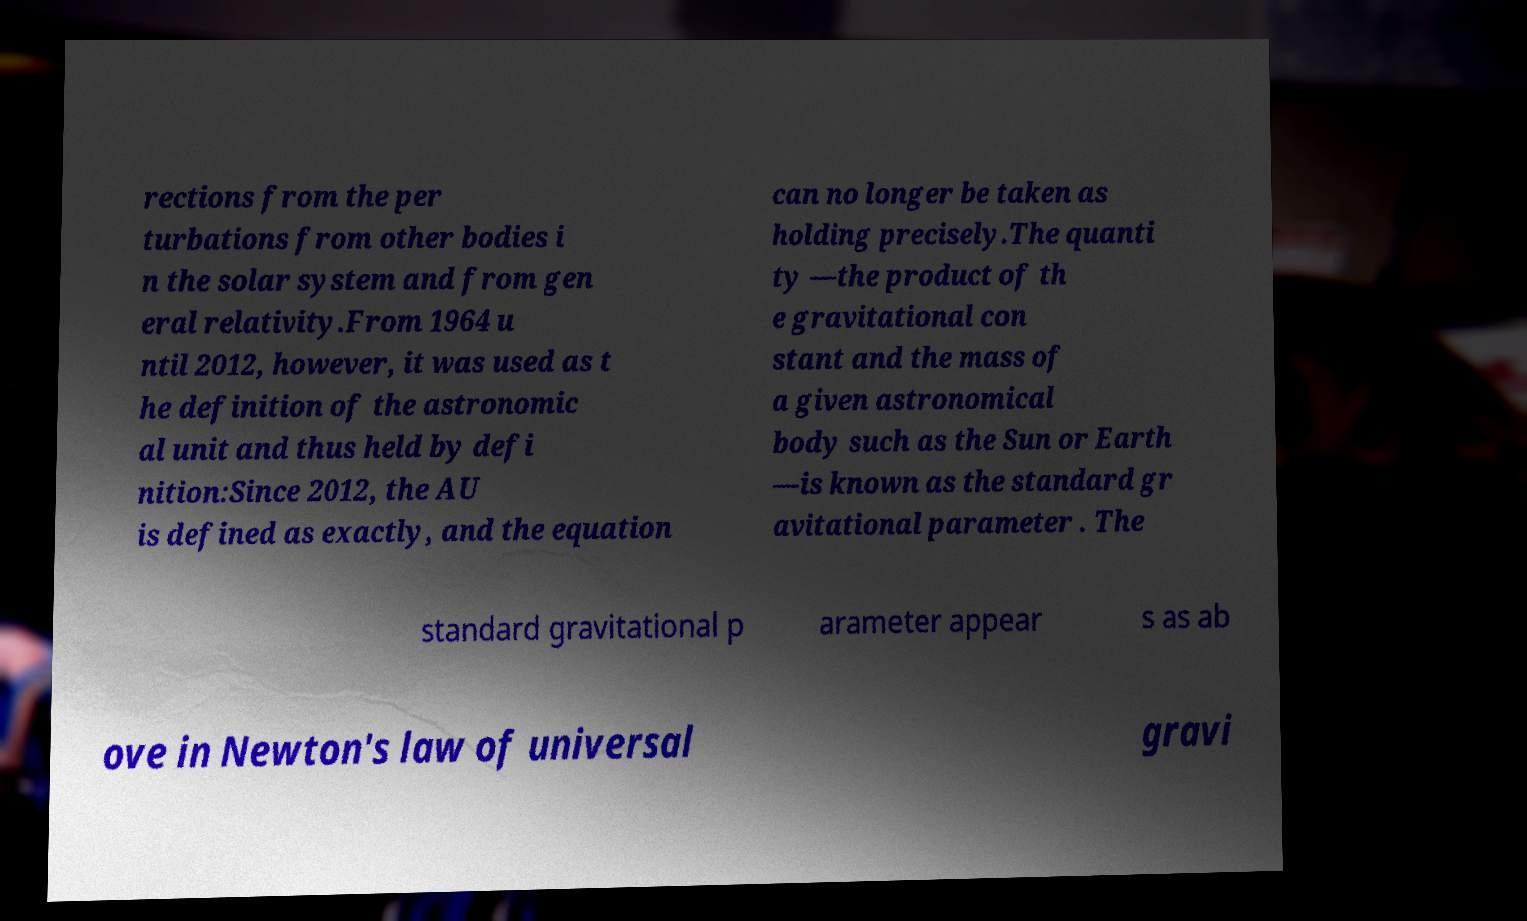Could you assist in decoding the text presented in this image and type it out clearly? rections from the per turbations from other bodies i n the solar system and from gen eral relativity.From 1964 u ntil 2012, however, it was used as t he definition of the astronomic al unit and thus held by defi nition:Since 2012, the AU is defined as exactly, and the equation can no longer be taken as holding precisely.The quanti ty —the product of th e gravitational con stant and the mass of a given astronomical body such as the Sun or Earth —is known as the standard gr avitational parameter . The standard gravitational p arameter appear s as ab ove in Newton's law of universal gravi 